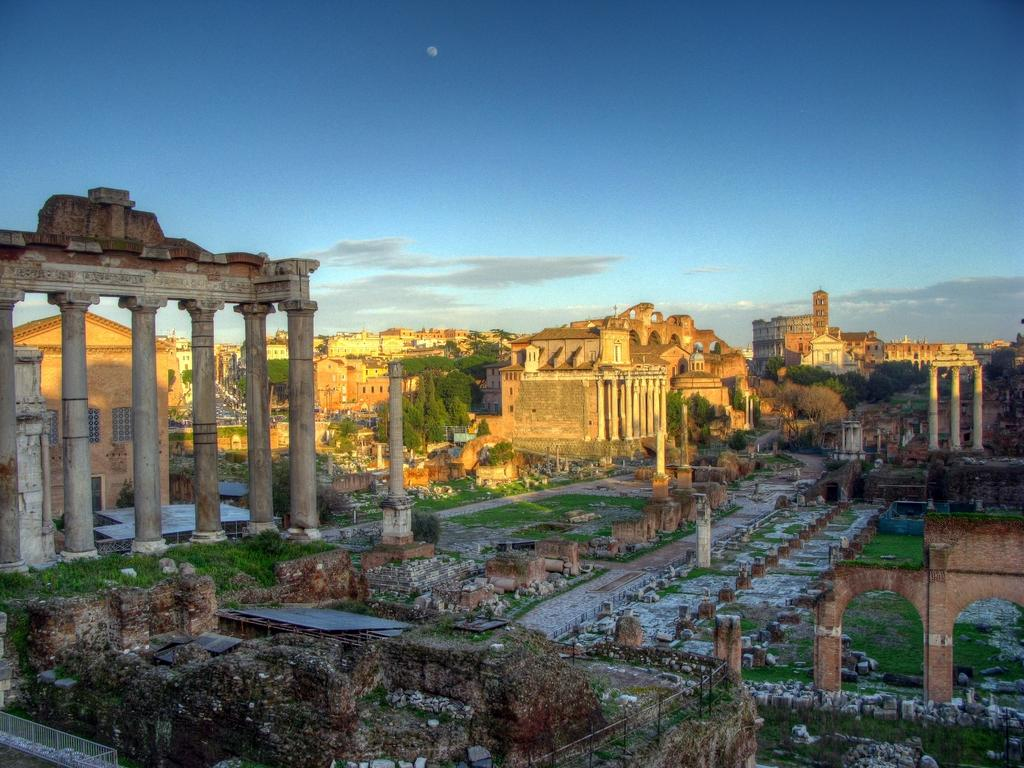What type of structures can be seen in the image? There are monuments in the image. What type of vegetation is present in the image? There are trees and grass in the image. What can be seen in the background of the image? The sky is visible in the background of the image. What type of lunch is being served at the monuments in the image? There is no indication of lunch or any food being served in the image. 